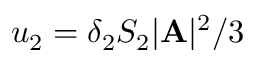<formula> <loc_0><loc_0><loc_500><loc_500>u _ { 2 } = \delta _ { 2 } S _ { 2 } | { A } | ^ { 2 } / 3</formula> 